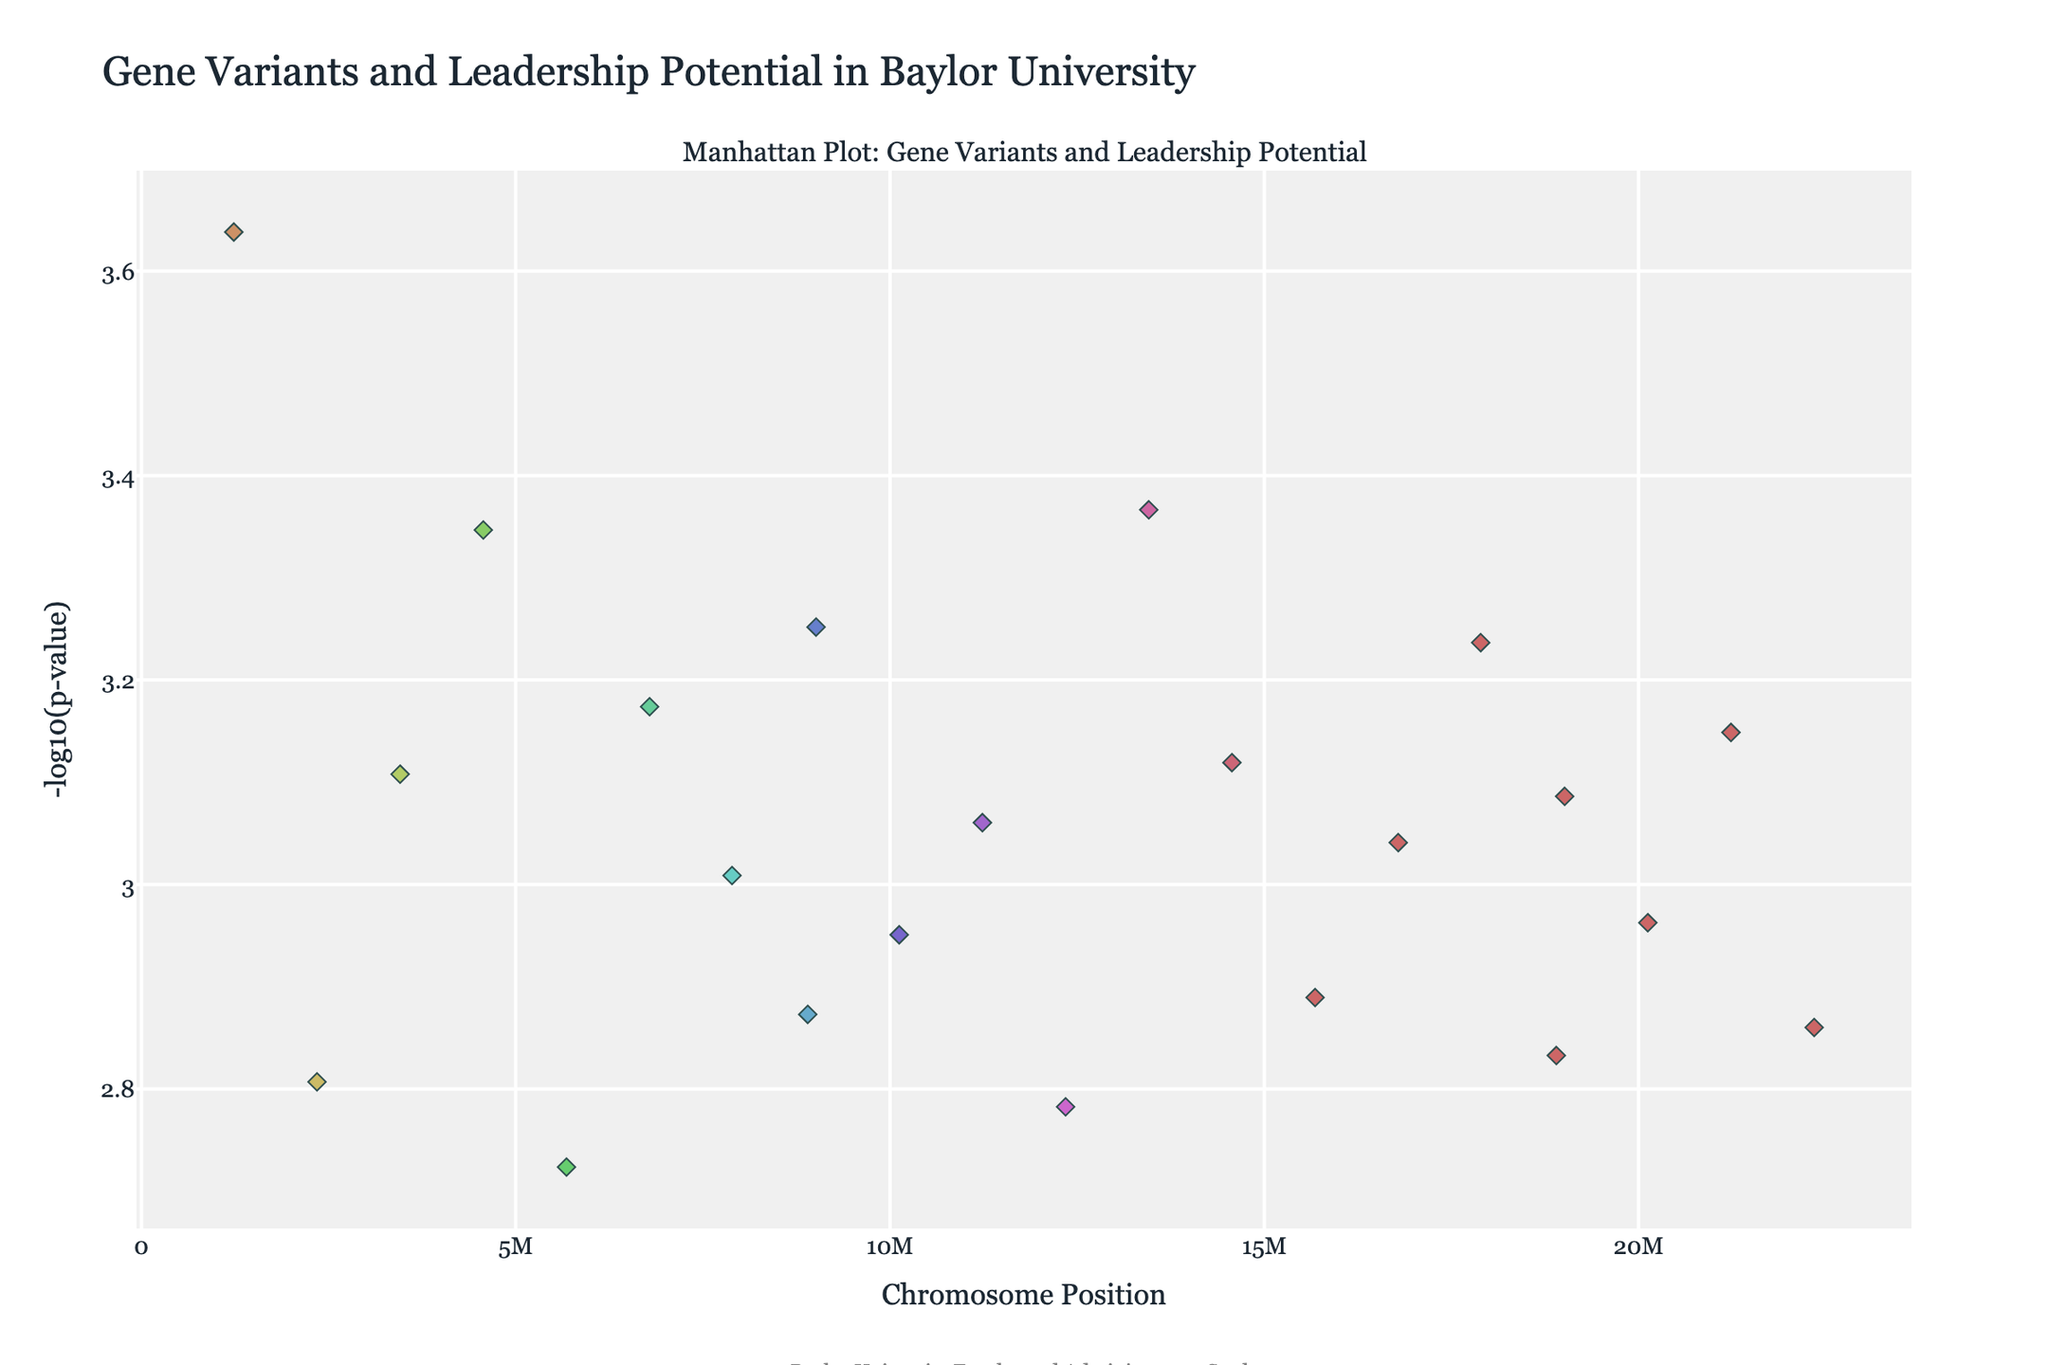What is the title of the plot? The title can be found at the top of the plot. It reads "Gene Variants and Leadership Potential in Baylor University".
Answer: Gene Variants and Leadership Potential in Baylor University Which chromosome has the gene with the smallest p-value? The smallest p-value corresponds to the highest -log10(p-value). By inspecting the y-axis, you identify the peak point and locate it on the x-axis, which corresponds to chromosome 1. The gene associated with this point is OXTR.
Answer: Chromosome 1 How many chromosomes are represented in this plot? Each unique color represents a different chromosome. By counting the distinct colors or chromosome legends, you see there are 22 chromosomes.
Answer: 22 Which gene has a -log10(p-value) closest to 3.5? By looking at the y-axis and finding the point closest to 3.5, you can see that the position corresponds to the gene OXTR on chromosome 1.
Answer: OXTR Compare the p-values of DRD2 and FOXP2 and determine which one is smaller. First, look at the positions for DRD2 on chromosome 13 and FOXP2 on chromosome 14. The point for DRD2 appears higher on the y-axis indicating a smaller p-value than the point for FOXP2.
Answer: DRD2 Which chromosomes have genes with -log10(p-values) greater than 3? By inspecting the y-axis and identifying the points above 3, you can see that chromosomes 1 (OXTR) and 13 (DRD2) have such points.
Answer: Chromosomes 1 and 13 What is the -log10(p-value) of the gene COMT on chromosome 3? Trace the point located on chromosome 3. The corresponding y-axis value indicates the -log10(p-value) of COMT is around 3.1.
Answer: Around 3.1 What is the average -log10(p-value) for genes with values greater than 3? Identify the points above 3 on the y-axis, which are OXTR (3.64), DRD2 (3.37), SLC6A4 (3.35). The average is calculated as (3.64 + 3.37 + 3.35) / 3.
Answer: 3.45 How do the number of significant genes (-log10(p-value) above 3) compare between chromosomes 1 and 4? There is 1 significant gene on chromosome 1 (OXTR) and 1 on chromosome 4 (SLC6A4). Hence, they have the same number of significant genes.
Answer: Same number Which gene on chromosome 2 has the highest -log10(p-value) and what is the value? There is only one gene listed for chromosome 2, DRD4. By checking the plot, the -log10(p-value) for DRD4 is around 2.8.
Answer: DRD4, around 2.8 